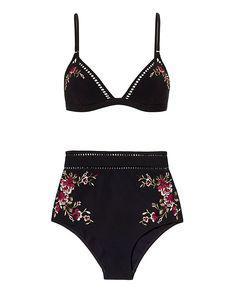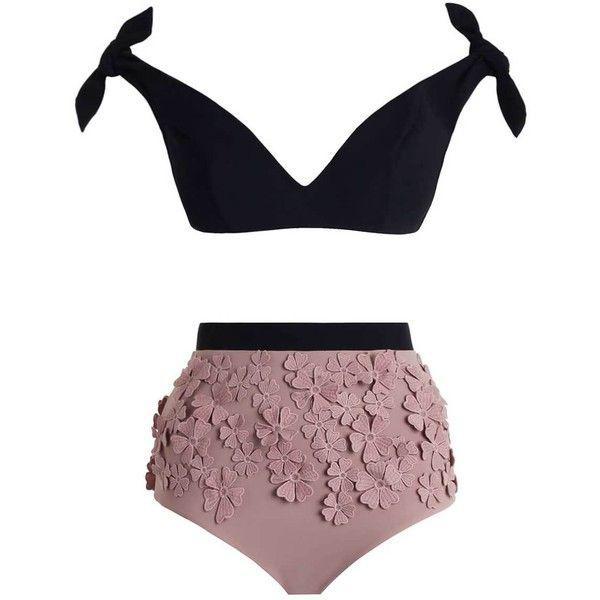The first image is the image on the left, the second image is the image on the right. Given the left and right images, does the statement "One bikini has a tieable strap." hold true? Answer yes or no. Yes. 